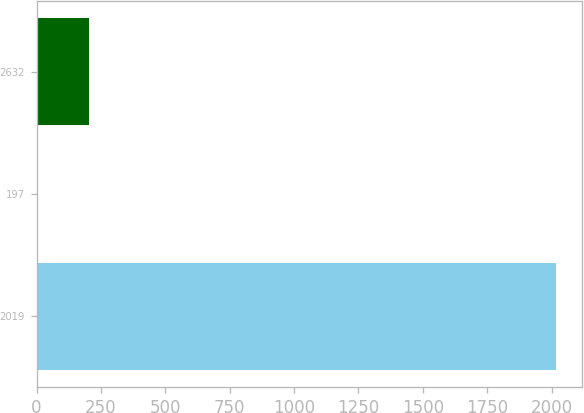Convert chart. <chart><loc_0><loc_0><loc_500><loc_500><bar_chart><fcel>2019<fcel>197<fcel>2632<nl><fcel>2017<fcel>1.14<fcel>202.73<nl></chart> 